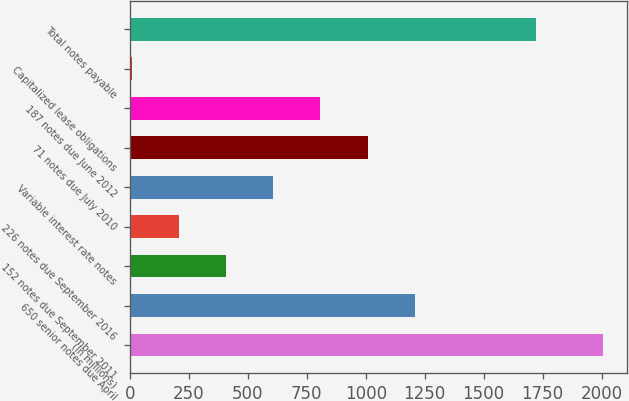<chart> <loc_0><loc_0><loc_500><loc_500><bar_chart><fcel>(In millions)<fcel>650 senior notes due April<fcel>152 notes due September 2011<fcel>226 notes due September 2016<fcel>Variable interest rate notes<fcel>71 notes due July 2010<fcel>187 notes due June 2012<fcel>Capitalized lease obligations<fcel>Total notes payable<nl><fcel>2008<fcel>1208<fcel>408<fcel>208<fcel>608<fcel>1008<fcel>808<fcel>8<fcel>1721<nl></chart> 